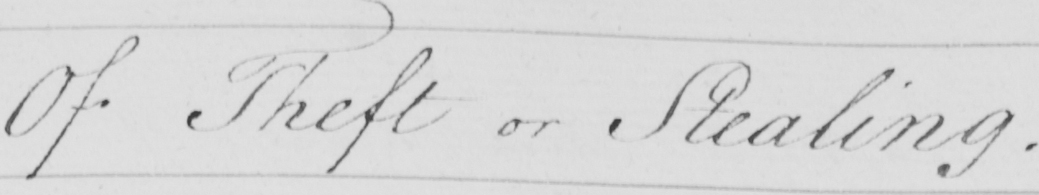What text is written in this handwritten line? Of Theft or Stealing 